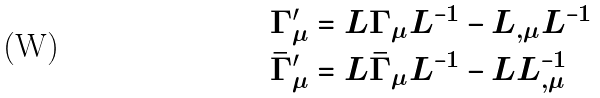Convert formula to latex. <formula><loc_0><loc_0><loc_500><loc_500>\Gamma _ { \mu } ^ { \prime } & = L \Gamma _ { \mu } L ^ { - 1 } - L _ { , \mu } L ^ { - 1 } \\ \bar { \Gamma } _ { \mu } ^ { \prime } & = L \bar { \Gamma } _ { \mu } L ^ { - 1 } - L L ^ { - 1 } _ { , \mu }</formula> 